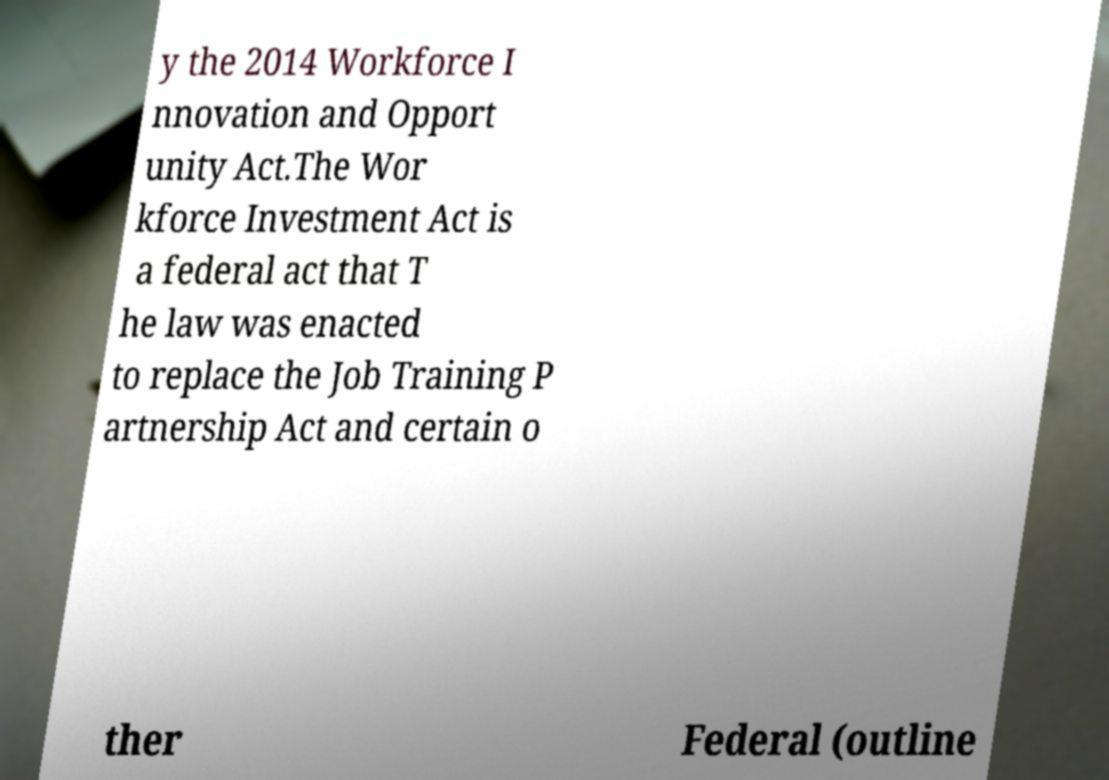Could you extract and type out the text from this image? y the 2014 Workforce I nnovation and Opport unity Act.The Wor kforce Investment Act is a federal act that T he law was enacted to replace the Job Training P artnership Act and certain o ther Federal (outline 